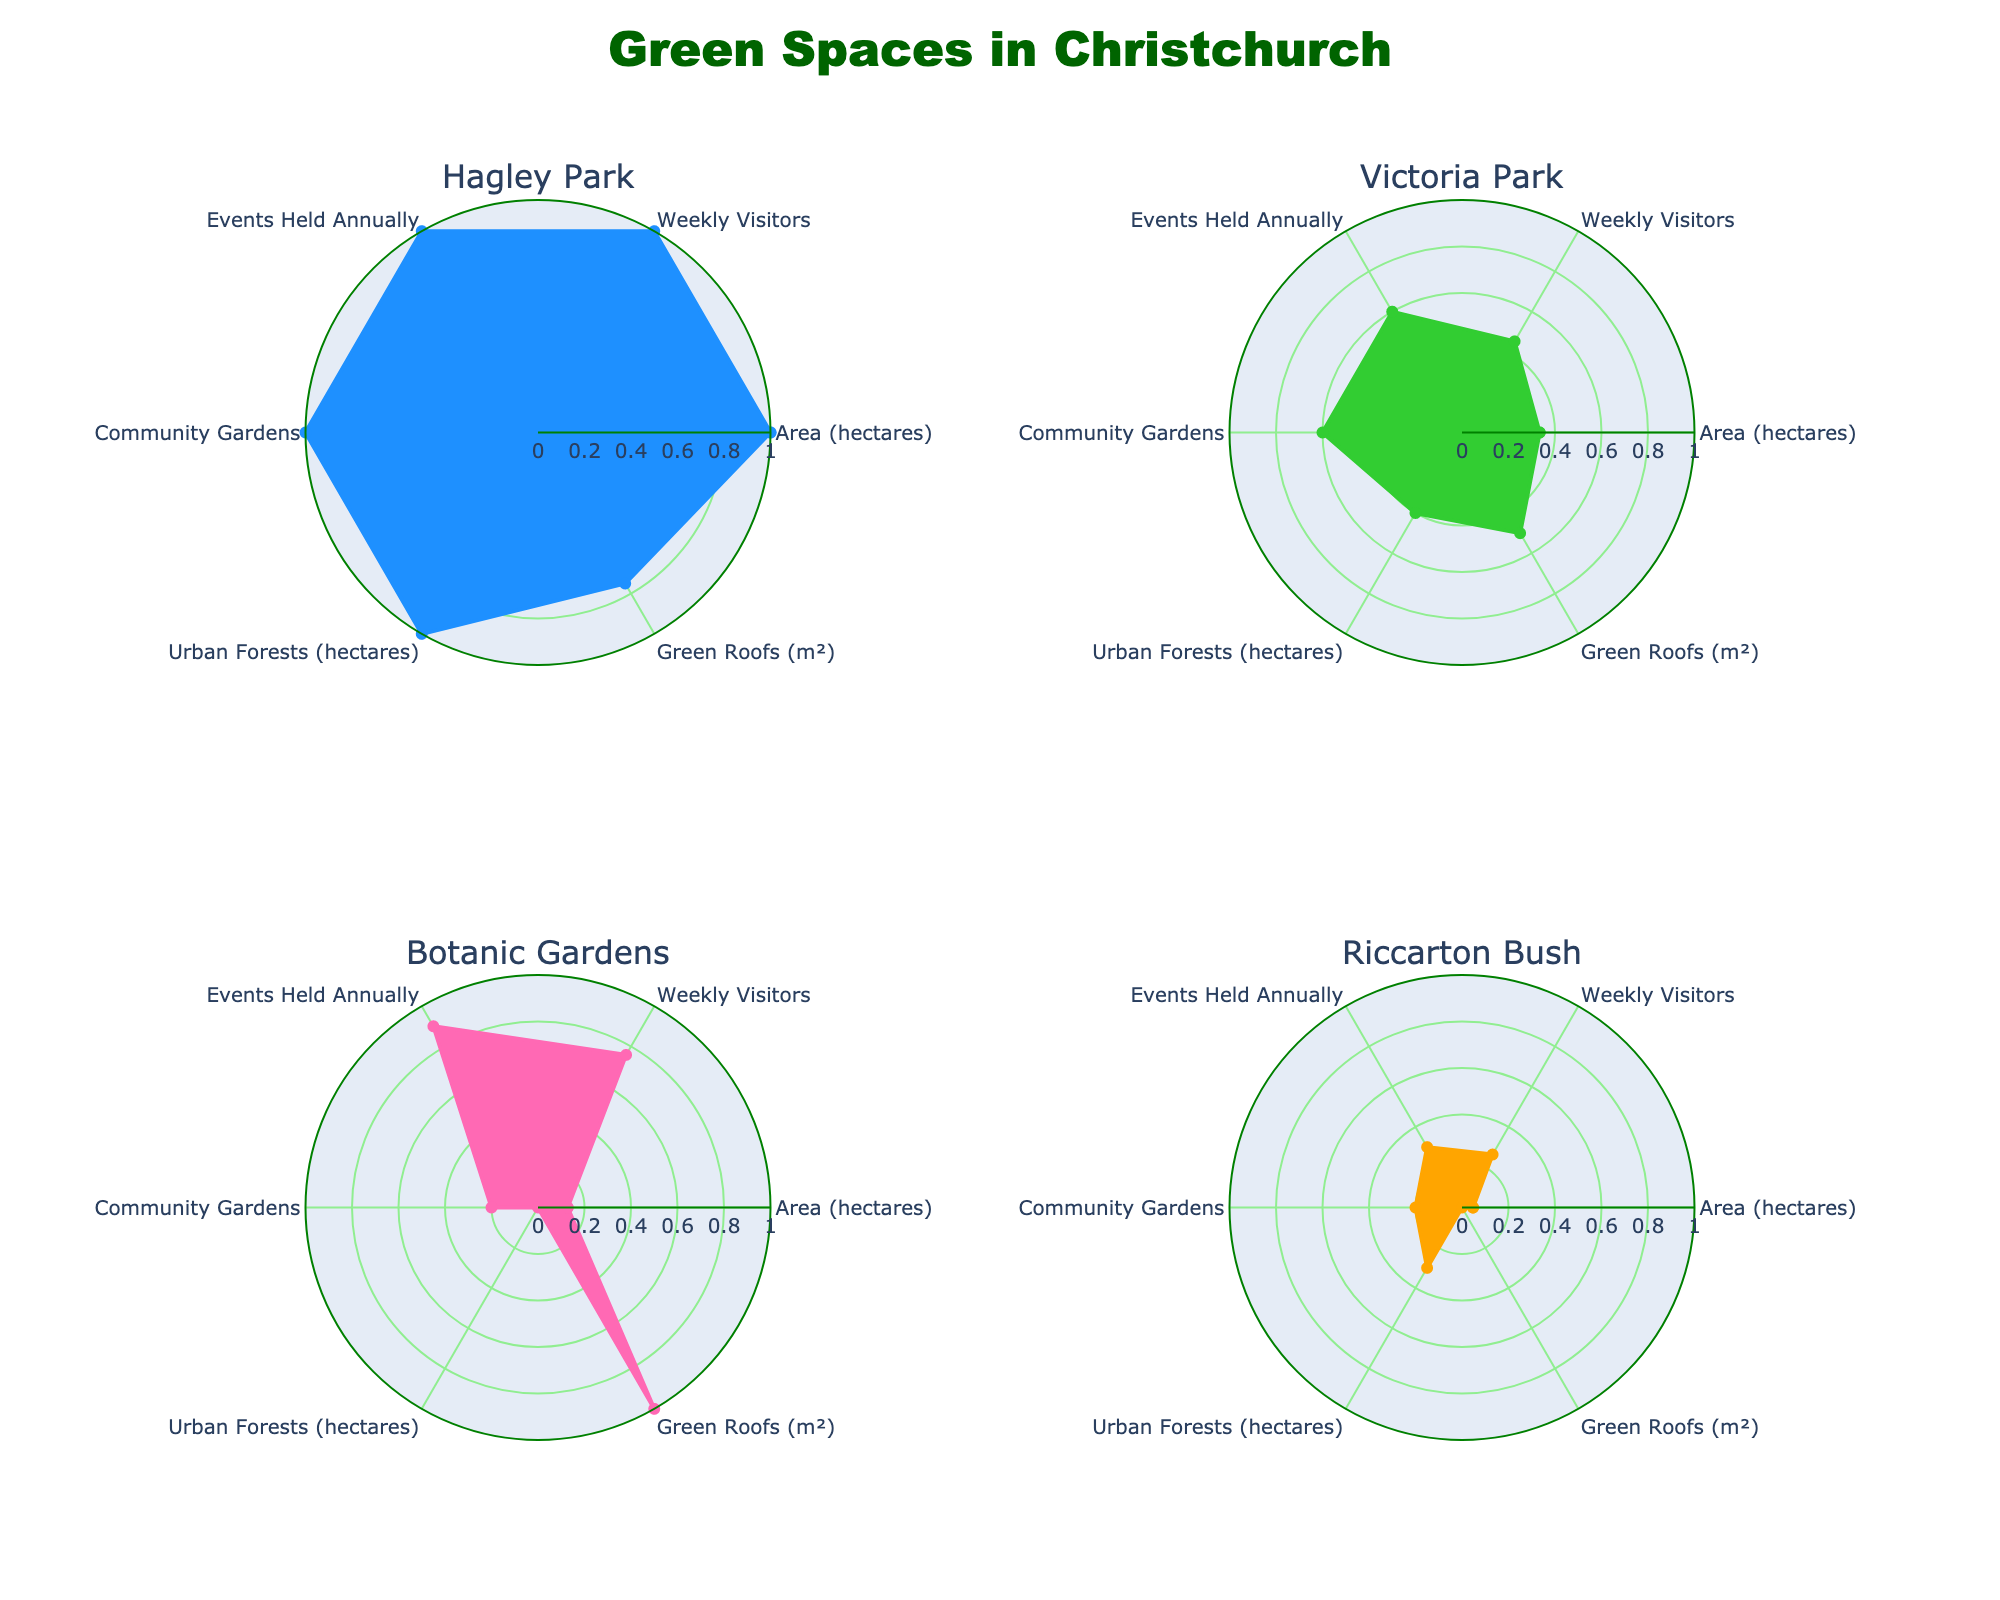What is the title of the figure? The title is usually found at the top of the figure. In this case, it states, "Green Spaces in Christchurch."
Answer: Green Spaces in Christchurch What is the color scheme used for the different radar charts? There are four radar charts, each with a distinct color representing different green spaces. They use blue, green, pink, and orange.
Answer: Blue, green, pink, and orange Which green space has the highest normalized value for 'Weekly Visitors?' To determine this, we look at the 'Weekly Visitors' axis and see which segment extends furthest from the center. In this case, it's Hagley Park.
Answer: Hagley Park How many green spaces are represented in the radar charts? Each subplot represents one green space. Since there are four subplots, there are four green spaces represented.
Answer: Four Which green space has the lowest normalized value for 'Community Gardens?' The radar chart segment for 'Community Gardens' is shortest for the space that has the lowest normalized value. Here, Botanic Gardens shows the lowest value.
Answer: Botanic Gardens Between Hagley Park and Victoria Park, which one holds more events annually? By comparing the 'Events Held Annually' segments on their radar charts, Hagley Park has a longer segment, meaning it holds more events annually than Victoria Park.
Answer: Hagley Park What green space has the highest combined normalized values for 'Area' and 'Urban Forests?' To answer this, sum the normalized values for 'Area (hectares)' and 'Urban Forests (hectares)' for each space and compare. Hagley Park stands out with the highest combined values.
Answer: Hagley Park Which green space shows the highest total normalized score across all categories? Each radar chart show's a space's overall utilization. The green space with the most extended cover across all axes is Hagley Park.
Answer: Hagley Park Which green space has the least variation in its normalized values across all categories? Variation can be assessed by noticing the consistency in segment lengths. Botanic Gardens shows the least variation with most segments being relatively similar in length.
Answer: Botanic Gardens In terms of 'Green Roofs,' which green space stands out the most? By examining the 'Green Roofs' segment, Botanic Gardens has the highest normalized value making it stand out the most.
Answer: Botanic Gardens 